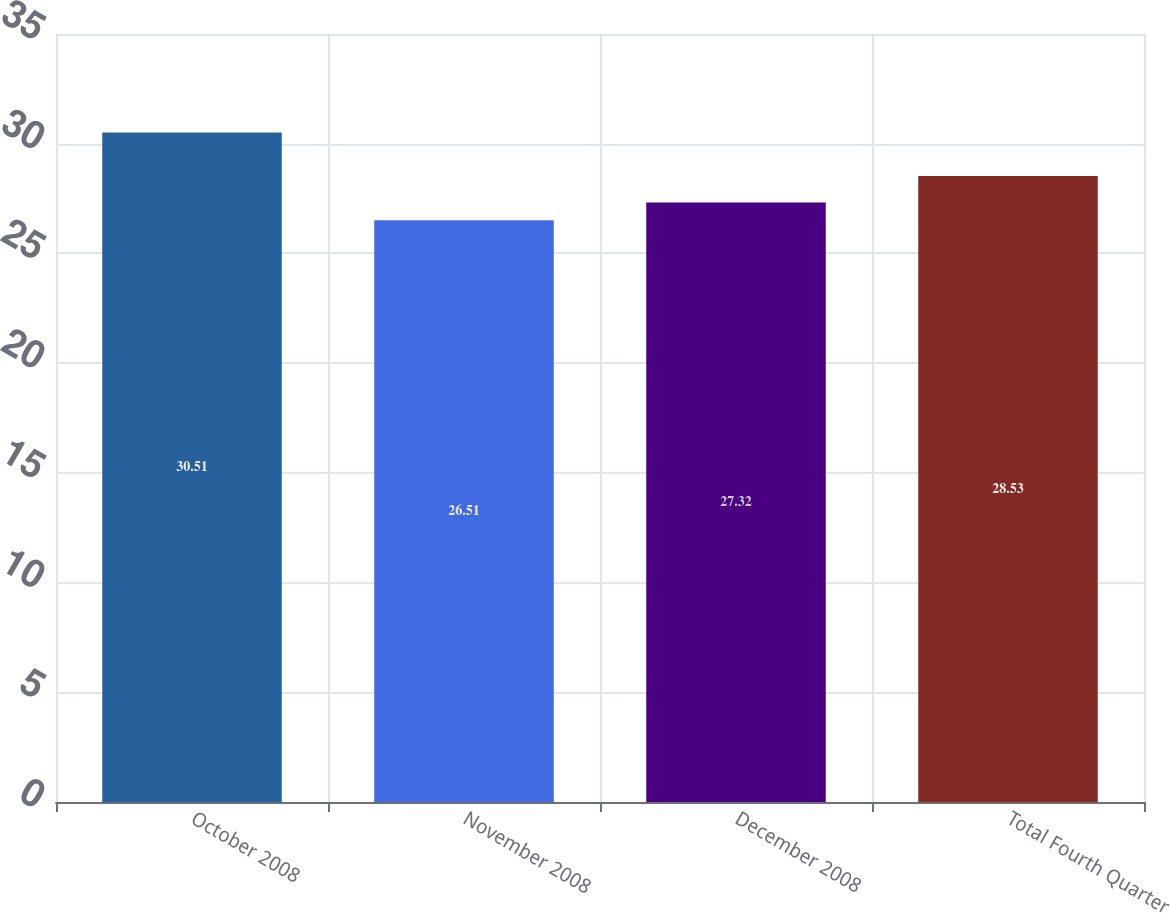Convert chart. <chart><loc_0><loc_0><loc_500><loc_500><bar_chart><fcel>October 2008<fcel>November 2008<fcel>December 2008<fcel>Total Fourth Quarter<nl><fcel>30.51<fcel>26.51<fcel>27.32<fcel>28.53<nl></chart> 